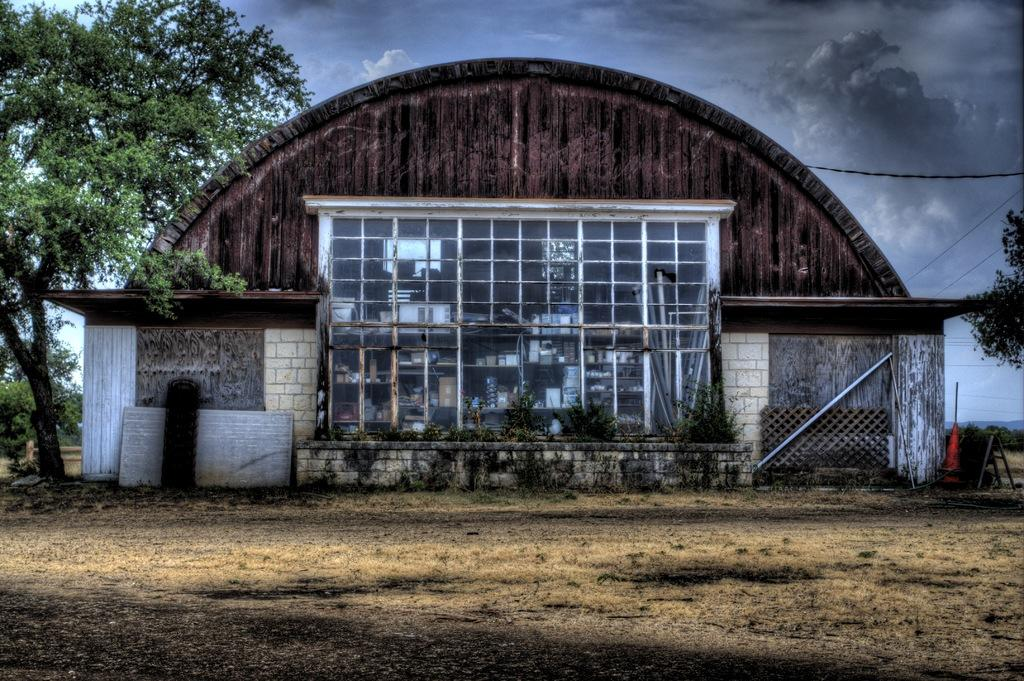What type of structure is visible in the image? There is a house in the image. What feature of the house can be seen in the image? There is a glass window in the image. What other objects are present in the image? There are poles, trees, wires, and a net in the image. What is the color of the sky in the image? The sky is blue and white in color. How many toes can be seen on the wood in the image? There is no wood or toes present in the image. What type of calculator is being used by the person in the image? There is no person or calculator present in the image. 